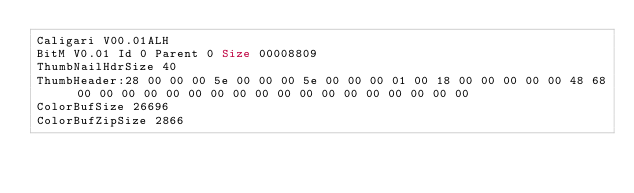Convert code to text. <code><loc_0><loc_0><loc_500><loc_500><_COBOL_>Caligari V00.01ALH             
BitM V0.01 Id 0 Parent 0 Size 00008809
ThumbNailHdrSize 40
ThumbHeader:28 00 00 00 5e 00 00 00 5e 00 00 00 01 00 18 00 00 00 00 00 48 68 00 00 00 00 00 00 00 00 00 00 00 00 00 00 00 00 00 00 
ColorBufSize 26696
ColorBufZipSize 2866</code> 